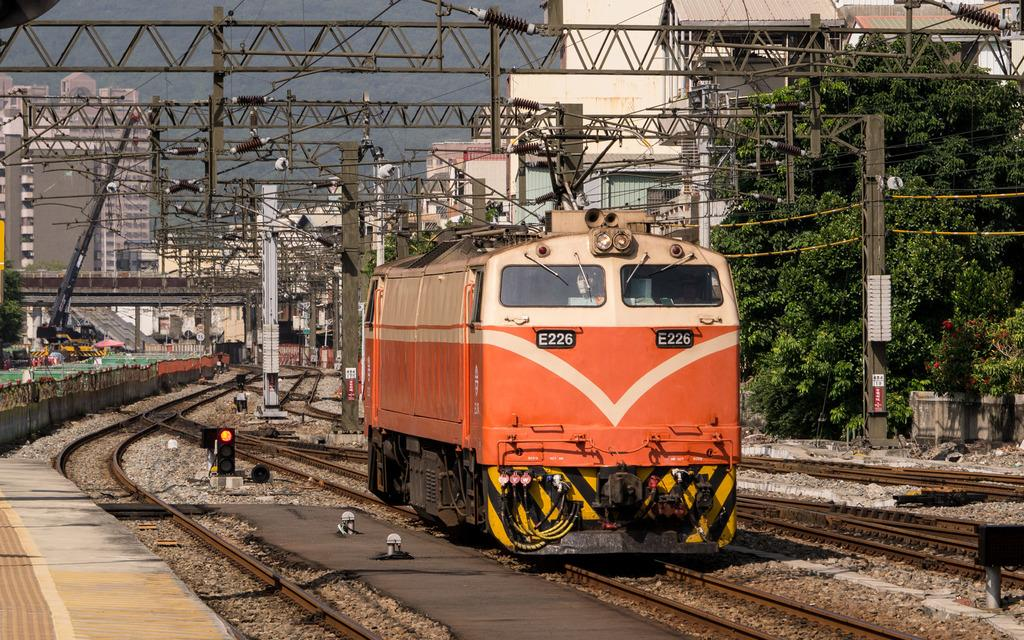<image>
Present a compact description of the photo's key features. A single orange train cart on the tracks numbered E226. 